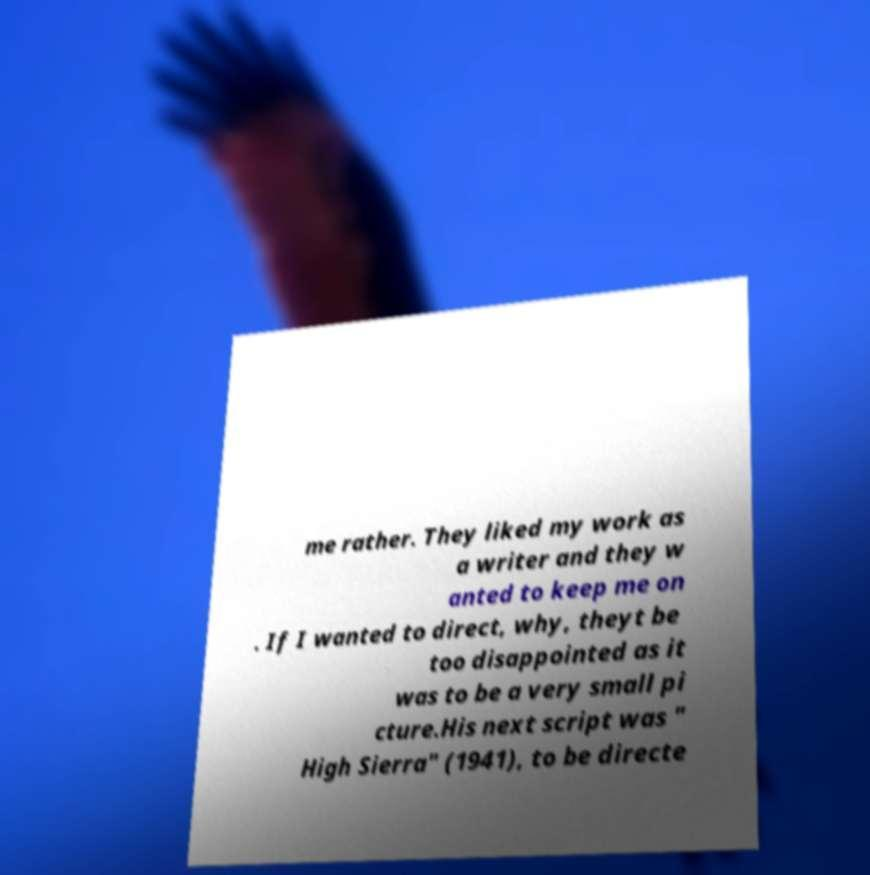Please read and relay the text visible in this image. What does it say? me rather. They liked my work as a writer and they w anted to keep me on . If I wanted to direct, why, theyt be too disappointed as it was to be a very small pi cture.His next script was " High Sierra" (1941), to be directe 